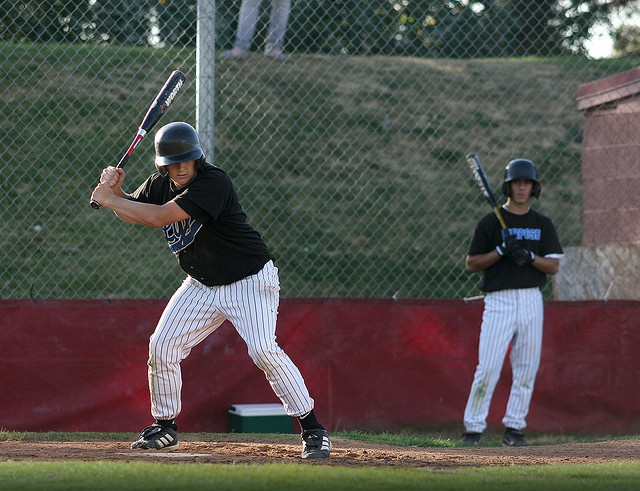Describe the objects in this image and their specific colors. I can see people in black, lavender, darkgray, and gray tones, people in black, darkgray, and gray tones, baseball bat in black, white, gray, and navy tones, and baseball bat in black, gray, darkgray, and darkgreen tones in this image. 